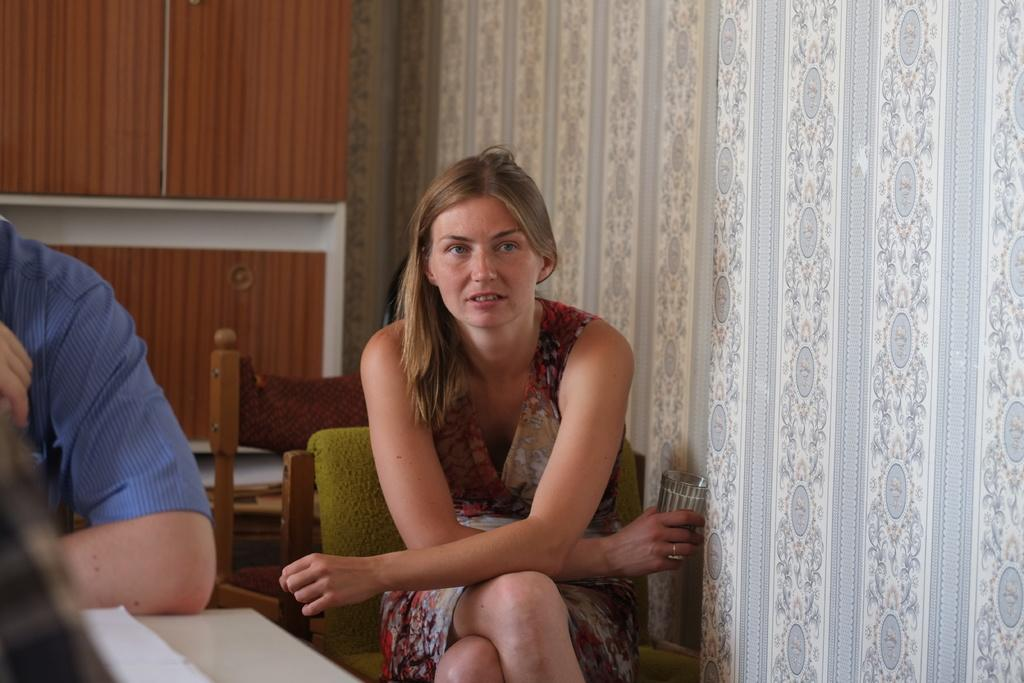What are the people in the image doing? The people in the image are sitting. What is located at the bottom of the image? There is a table at the bottom of the image. What can be seen in the background of the image? There is a wall and a cupboard visible in the background of the image. What type of snake is crawling on the table in the image? There is no snake present in the image; the table is empty. How many tickets are visible on the wall in the image? There are no tickets visible on the wall in the image; only a cupboard is present. 